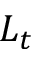Convert formula to latex. <formula><loc_0><loc_0><loc_500><loc_500>L _ { t }</formula> 